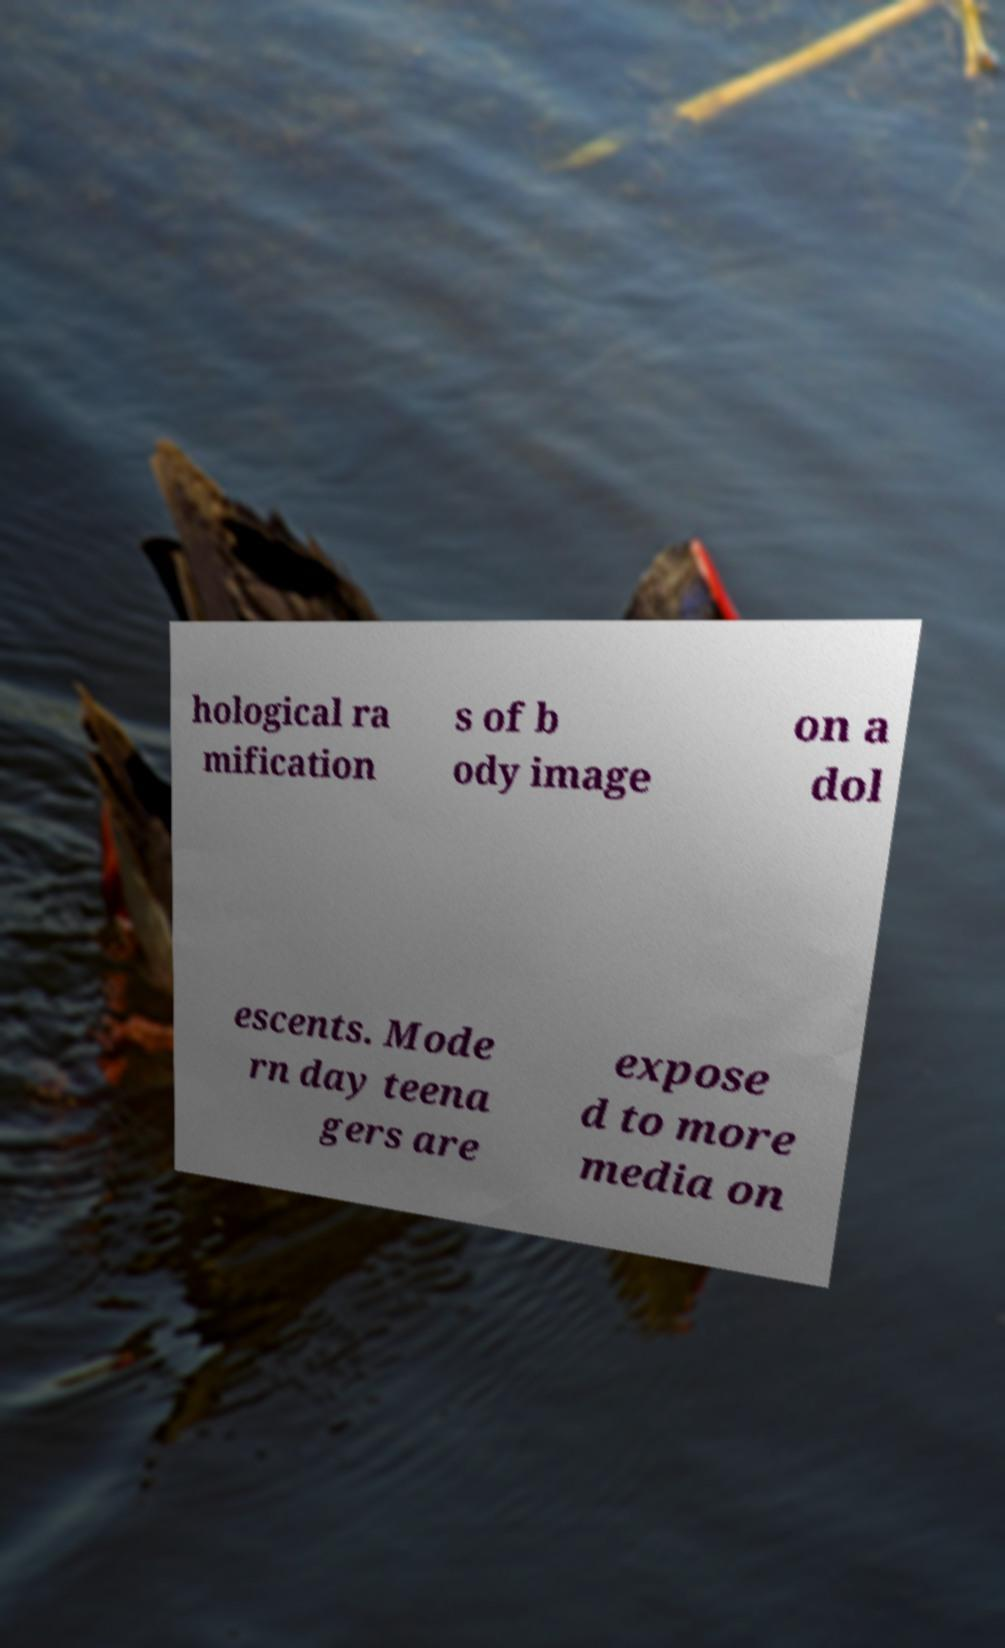Please read and relay the text visible in this image. What does it say? hological ra mification s of b ody image on a dol escents. Mode rn day teena gers are expose d to more media on 